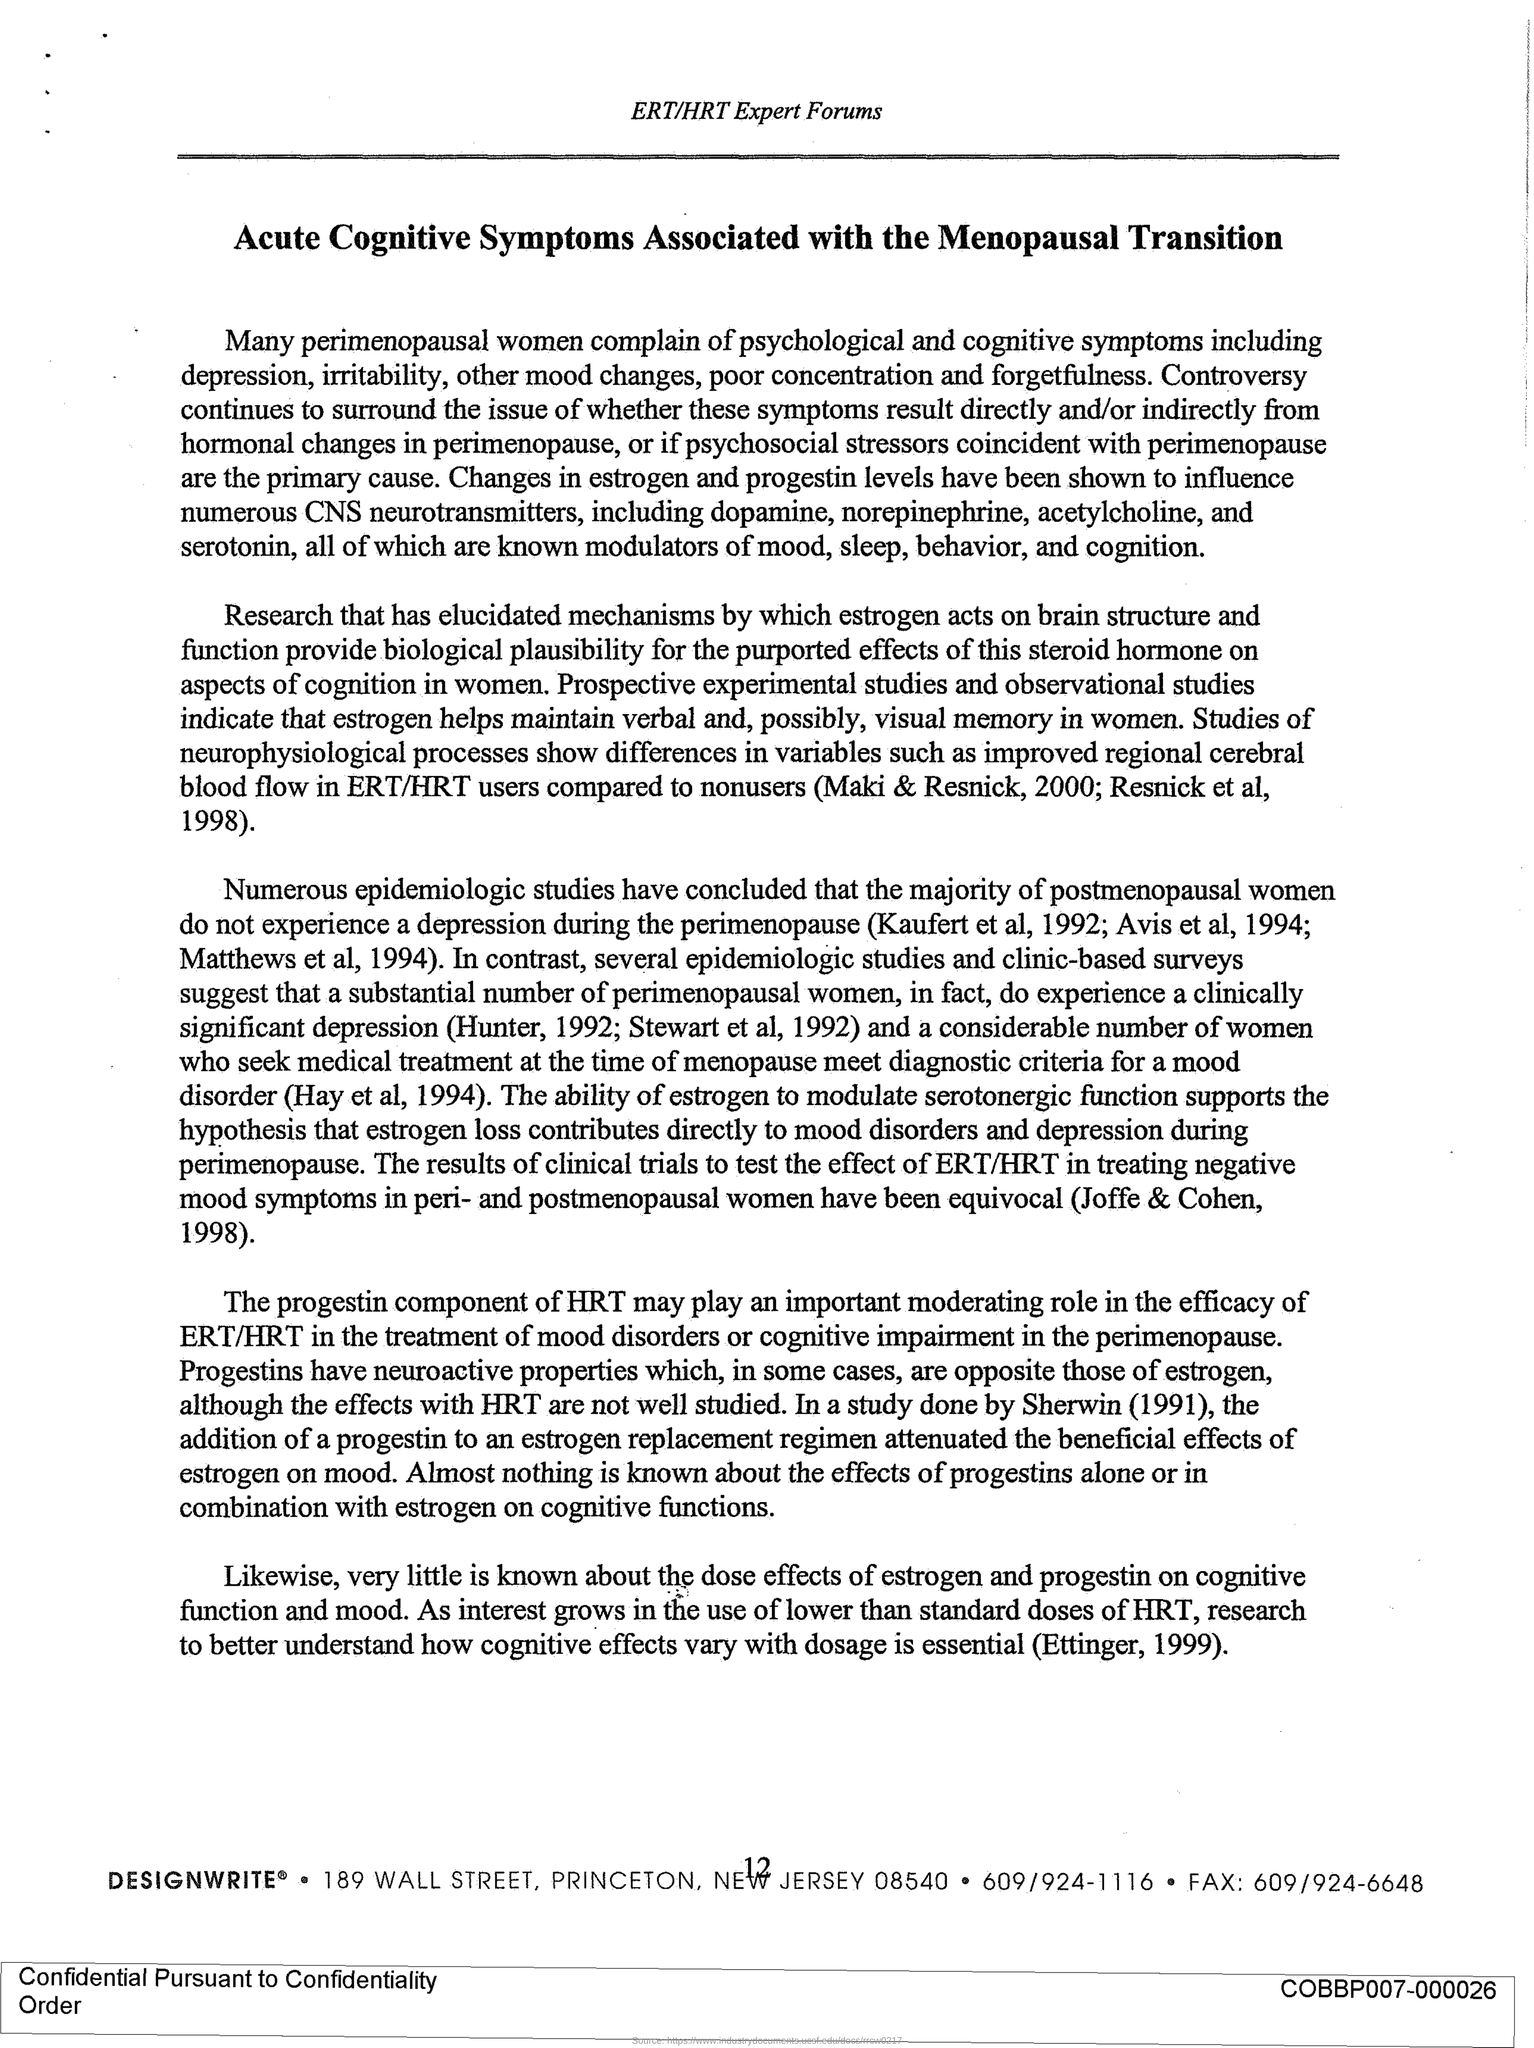Draw attention to some important aspects in this diagram. Perimenopausal women are those who experience psychological and cognitive symptoms and are the ones who complain about them. The heading of the document is "Acute Cognitive Symptoms Associated with the Menopausal Transition. Hormone replacement therapy (HRT) is a medical treatment that involves the use of hormones to alleviate symptoms of menopause or other hormonal imbalances. The progestin component of HRT plays an important role in the treatment of ERT/HRT. Perimenopausal women are those who commonly complain about psychological and cognitive symptoms. Postmenopausal women who do not experience depression are: 